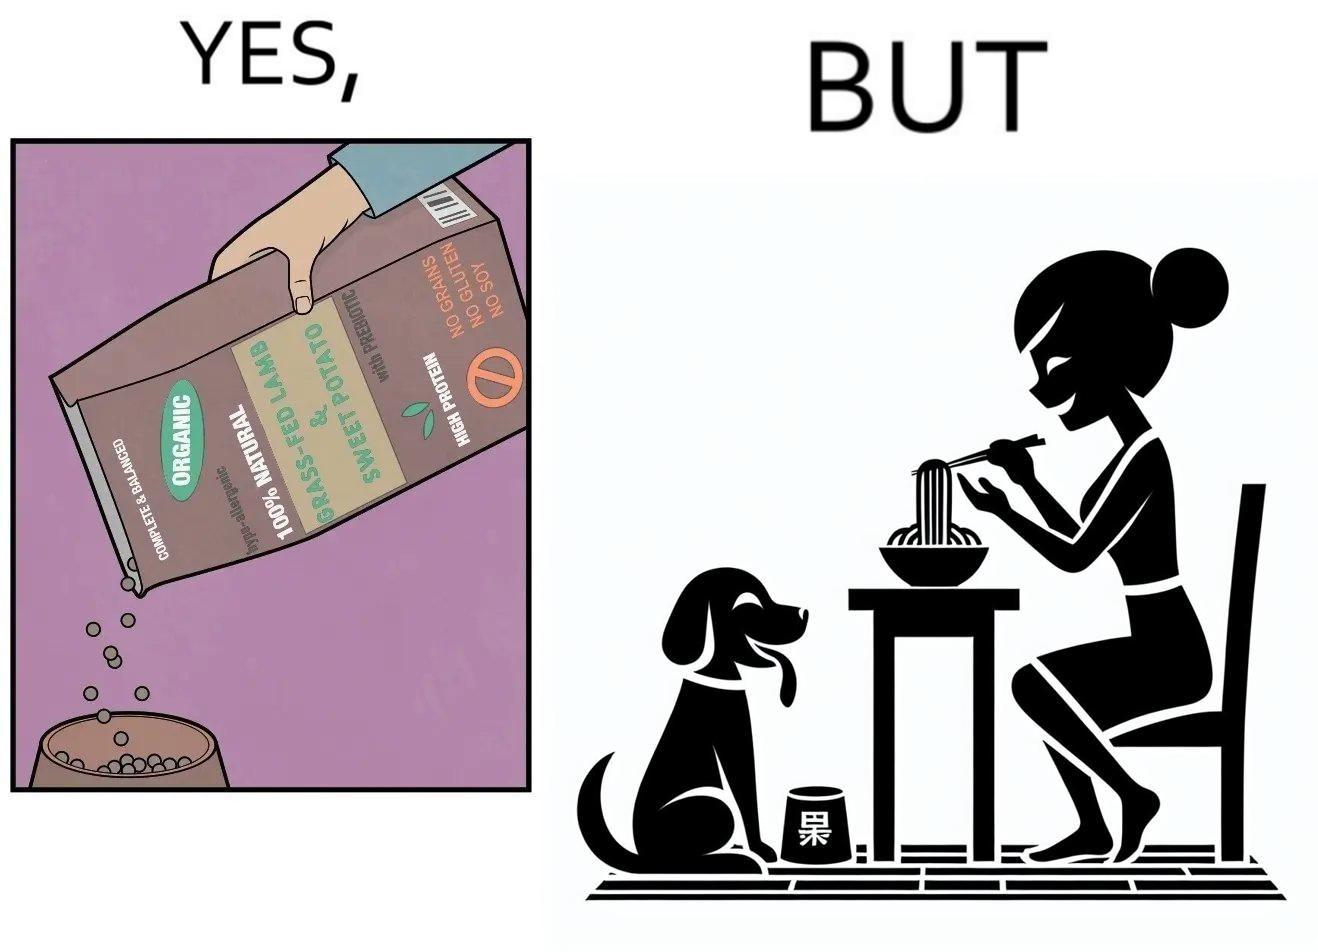Does this image contain satire or humor? Yes, this image is satirical. 